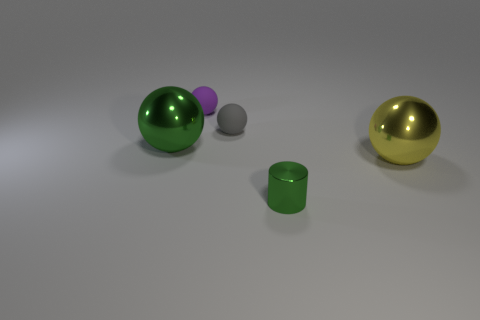There is a object that is behind the gray object; what is it made of?
Your response must be concise. Rubber. There is a gray sphere that is the same size as the purple ball; what material is it?
Your answer should be compact. Rubber. Is there a tiny green cylinder that has the same material as the large yellow thing?
Keep it short and to the point. Yes. Are there fewer matte things that are to the left of the purple sphere than tiny matte balls?
Make the answer very short. Yes. What material is the small green thing left of the shiny ball that is on the right side of the tiny cylinder?
Give a very brief answer. Metal. The small thing that is both in front of the small purple matte ball and behind the green cylinder has what shape?
Keep it short and to the point. Sphere. How many other things are the same color as the tiny shiny object?
Give a very brief answer. 1. What number of things are green things that are in front of the big yellow shiny object or rubber objects?
Keep it short and to the point. 3. There is a metallic cylinder; is its color the same as the big sphere to the left of the tiny purple object?
Keep it short and to the point. Yes. What size is the shiny ball in front of the metal ball that is to the left of the big yellow object?
Your answer should be very brief. Large. 